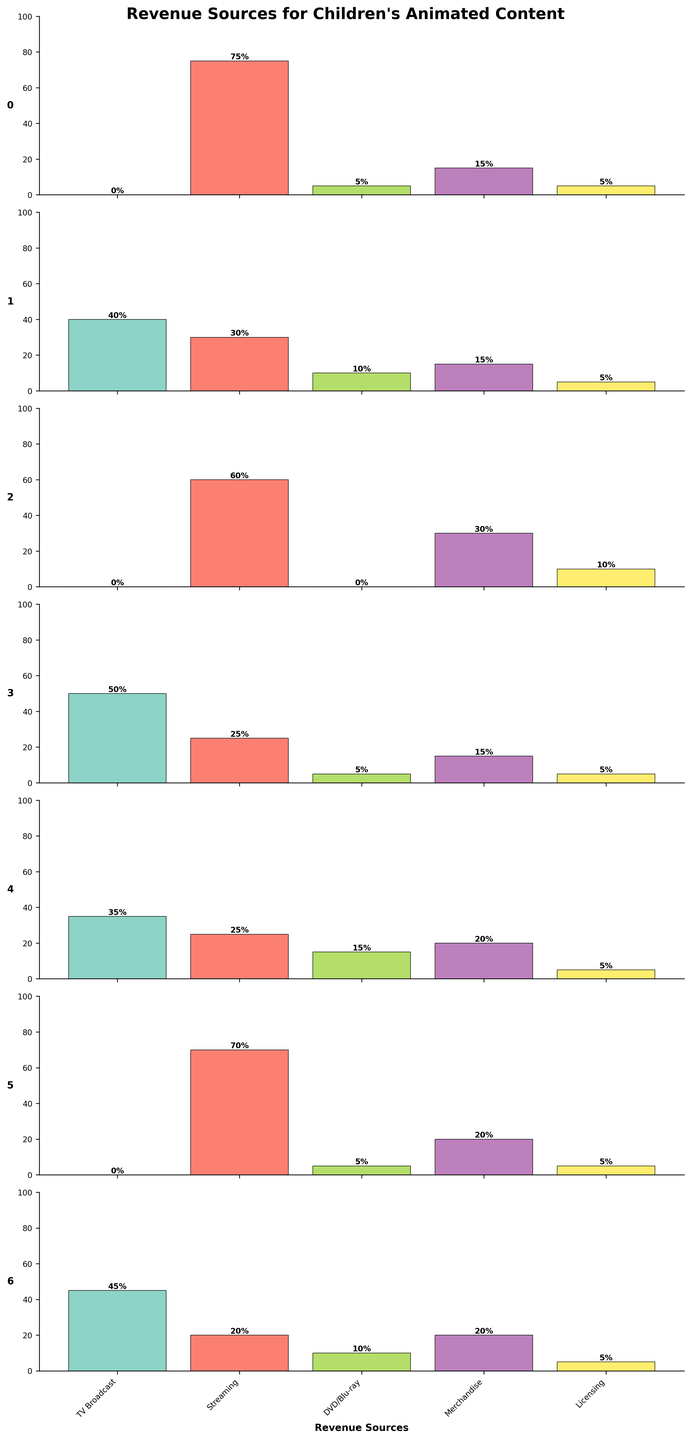What is the main title of the figure? The main title is located at the top of the figure and is typically the largest and boldest text, making it easy to identify. In this case, the title will be found at the very top of the image.
Answer: Revenue Sources for Children's Animated Content Which platform has the highest percentage of revenue from TV Broadcast? To find the answer, look at each subplot and identify the bar segment corresponding to "TV Broadcast." The platform with the tallest bar for "TV Broadcast" has the highest percentage.
Answer: PBS Kids What is the total revenue percentage from Merchandise for YouTube Kids and Amazon Prime Video combined? Locate the bars corresponding to Merchandise for YouTube Kids and Amazon Prime Video. Sum their respective percentages.
Answer: 30 + 20 = 50% Compare the revenue distributions of Netflix and Disney Channel. Which platform has a more diversified revenue source? Compare the bars for each revenue source category for both platforms. Netflix has most of its revenue from Streaming, whereas Disney Channel's revenue is more spread out across TV Broadcast, Streaming, DVD/Blu-ray, Merchandise, and Licensing.
Answer: Disney Channel Which platform has an equal percentage of revenue from Merchandise and Licensing? Look at each subplot to identify a platform that has the same height of bars for both Merchandise and Licensing.
Answer: Nickelodeon and Netflix How many platforms have 0% revenue from TV Broadcast? Check the "TV Broadcast" bar for each subplot and count how many platforms have no bar (height is 0).
Answer: 3 (Netflix, YouTube Kids, Amazon Prime Video) What is the average percentage of revenue from Streaming across all platforms? Add up the percentages for Streaming from each subplot and then divide by the number of platforms.
Answer: (75 + 30 + 60 + 25 + 25 + 70 + 20) / 7 = 43.57% Which platform has the largest percentage of revenue from Licensing? Identify the tallest bar segment for Licensing across all subplots.
Answer: YouTube Kids How does the revenue distribution for PBS Kids compare to the industry norm represented by other platforms? Compare the bars for each revenue category in PBS Kids to those of the other platforms. PBS Kids has a higher TV Broadcast revenue and lower Streaming revenue compared to the industry norm.
Answer: Higher TV Broadcast, Lower Streaming What is the total percentage of revenue coming from DVD/Blu-ray for all platforms combined? Sum the percentages of DVD/Blu-ray revenue from each platform.
Answer: 5 + 10 + 0 + 5 + 15 + 5 + 10 = 50% 